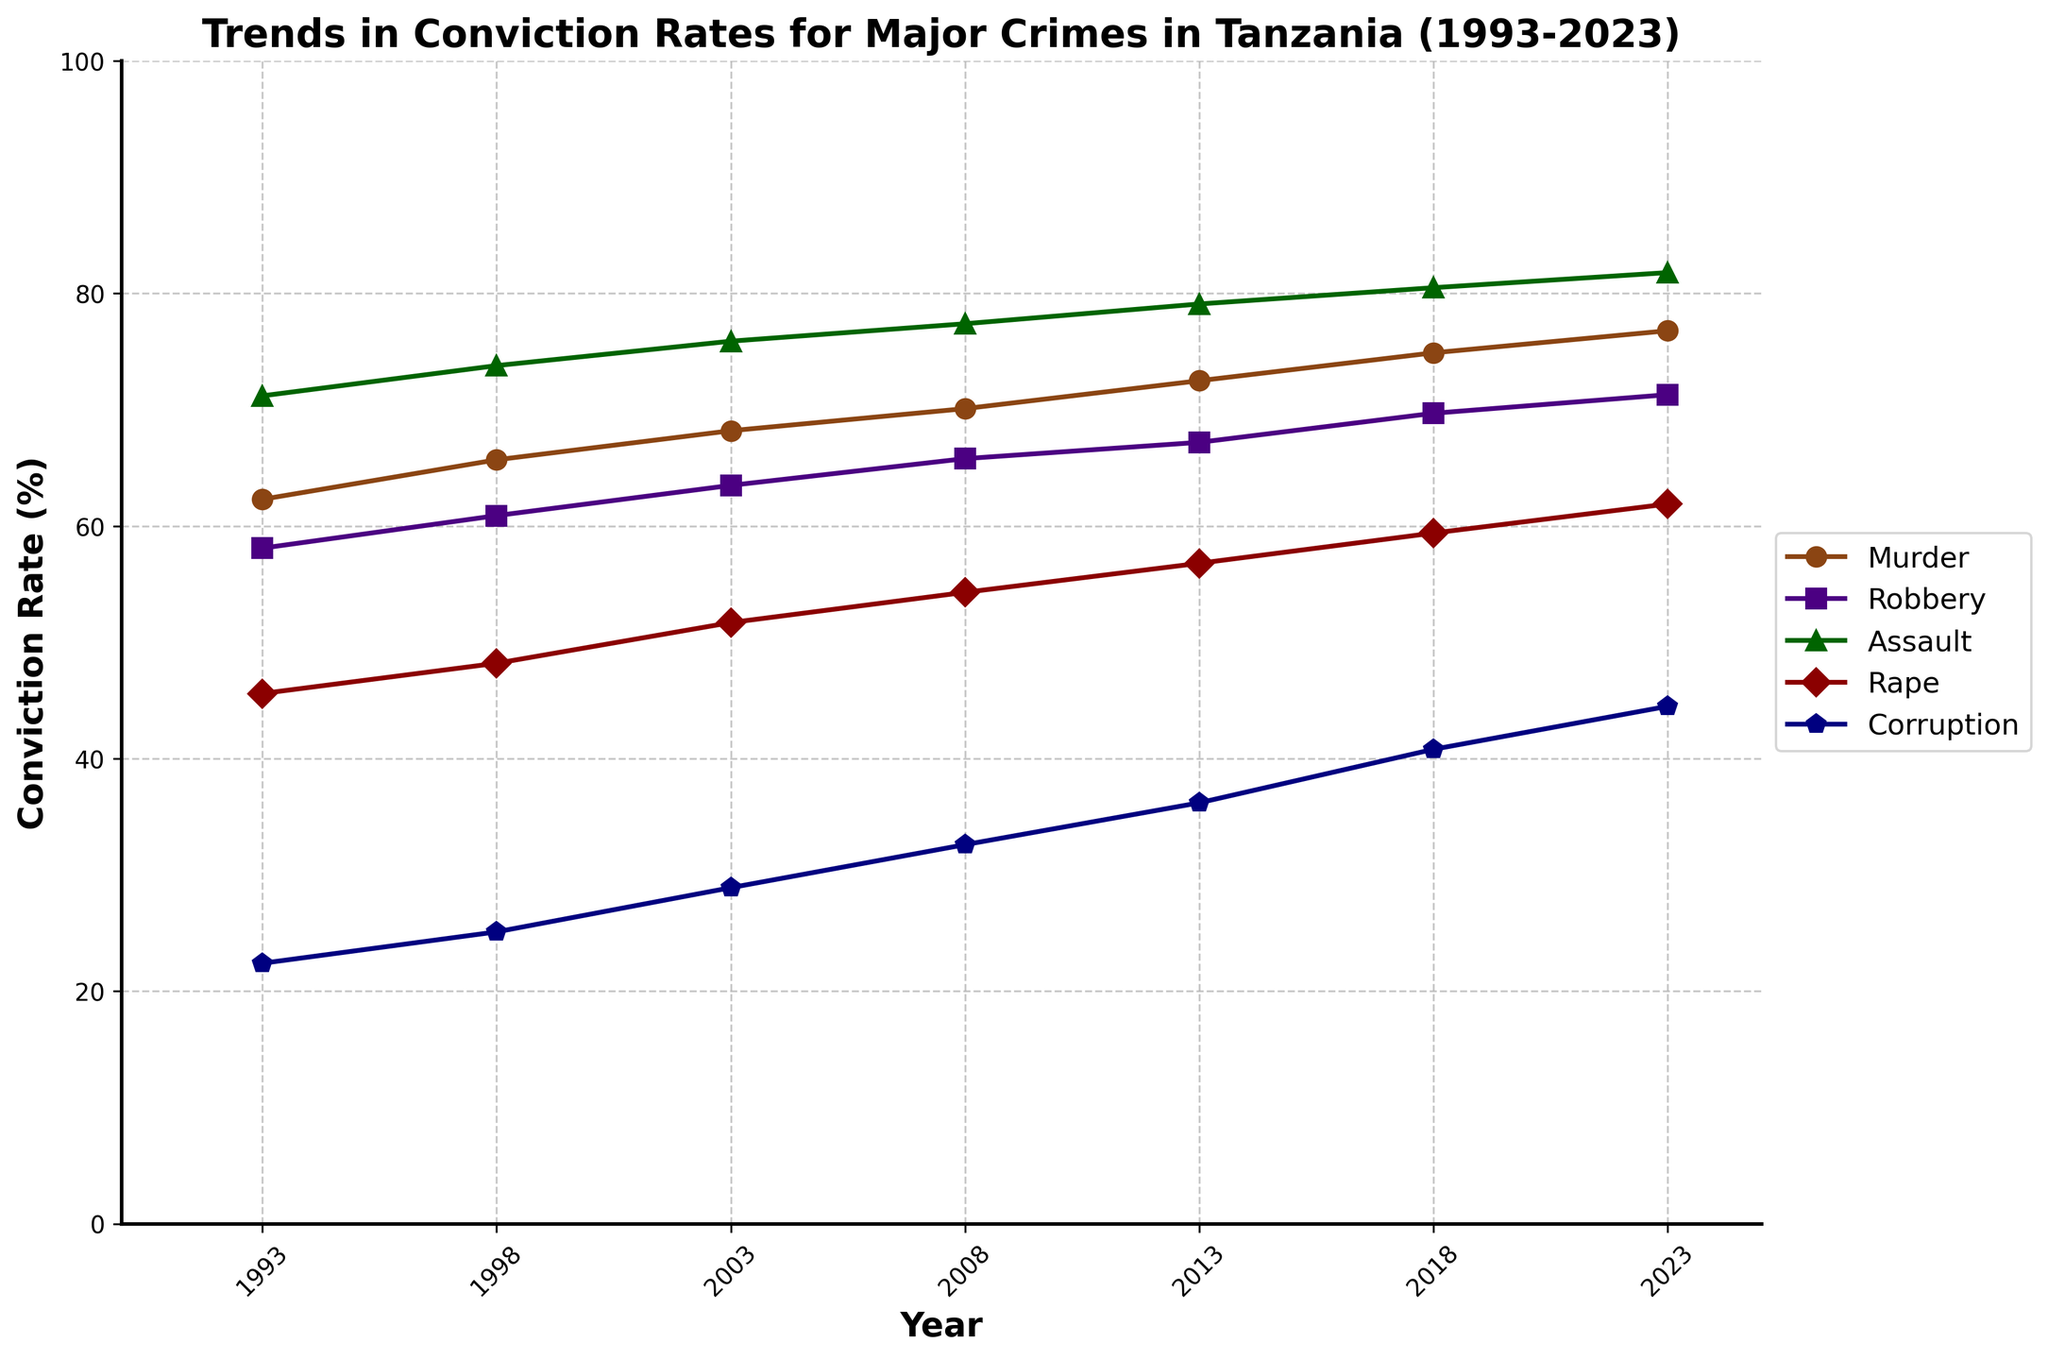What was the conviction rate for corruption in 2008? Locate the point corresponding to 'Corruption' on the x-axis at '2008'. The y-value next to it indicates the conviction rate.
Answer: 32.6% How did the conviction rate for robbery change from 1993 to 2023? Observe the 'Robbery' trend line. The value went from 58.1% in 1993 to 71.3% in 2023, showing an increase.
Answer: Increased Which crime had the highest conviction rate in 2018? Identify the highest point among all trends in 2018. 'Assault' had the highest rate at 80.5%.
Answer: Assault What is the average conviction rate for murder over the years shown? Sum the conviction rates for 'Murder' in all years provided: (62.3 + 65.7 + 68.2 + 70.1 + 72.5 + 74.9 + 76.8) and divide by the number of years (7).
Answer: 70.1% Between which two consecutive years did rape conviction rates increase the most? Calculate the differences in 'Rape' rates between consecutive years: 48.2-45.6, 51.7-48.2, 54.3-51.7, 56.8-54.3, 59.4-56.8, 61.9-59.4. The largest numerical difference is 3.5 between 2013 and 2018.
Answer: 2013 and 2018 Compare the trends for assault and murder. Which one had a steeper increase over time? Examine the slope of both trends. 'Assault' increased from 71.2% to 81.8%, while 'Murder' increased from 62.3% to 76.8%. The rate of increase for 'Assault' is 10.6, and for 'Murder' is 14.5. 'Murder' had a steeper increase.
Answer: Murder What is the difference in the conviction rates for murder and corruption in 2023? Locate the y-values for both 'Murder' and 'Corruption' in 2023. Subtract the rate for 'Corruption' from that for 'Murder': 76.8 - 44.5.
Answer: 32.3% Which crime showed the least variability in conviction rates from 1993 to 2023? Analyze the variance in each trend. 'Corruption' varies from 22.4% to 44.5%, a range of 22.1%. Compare ranges of other crimes and 'Corruption' has the smallest range.
Answer: Corruption What was the trend of the conviction rate for rape from 1993 to 2023? Observe the 'Rape' line graph from 1993 to 2023. The line continuously rises from 45.6% to 61.9%, indicating an upward trend.
Answer: Upward trend Which crime had the closest conviction rates to 50% in 2003? Locate conviction rates for all crimes at '2003' and find the one closest to 50%. 'Rape' had a value of 51.7%, which is the closest to 50%.
Answer: Rape 